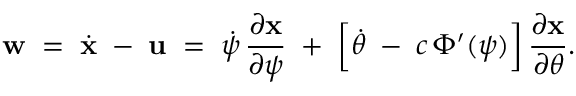<formula> <loc_0><loc_0><loc_500><loc_500>{ w } \, = \, \dot { x } \, - \, { u } \, = \, \dot { \psi } \, \frac { \partial x } { \partial \psi } \, + \, \left [ \dot { \theta } \, - { } c \, \Phi ^ { \prime } ( \psi ) \right ] \frac { \partial x } { \partial \theta } .</formula> 